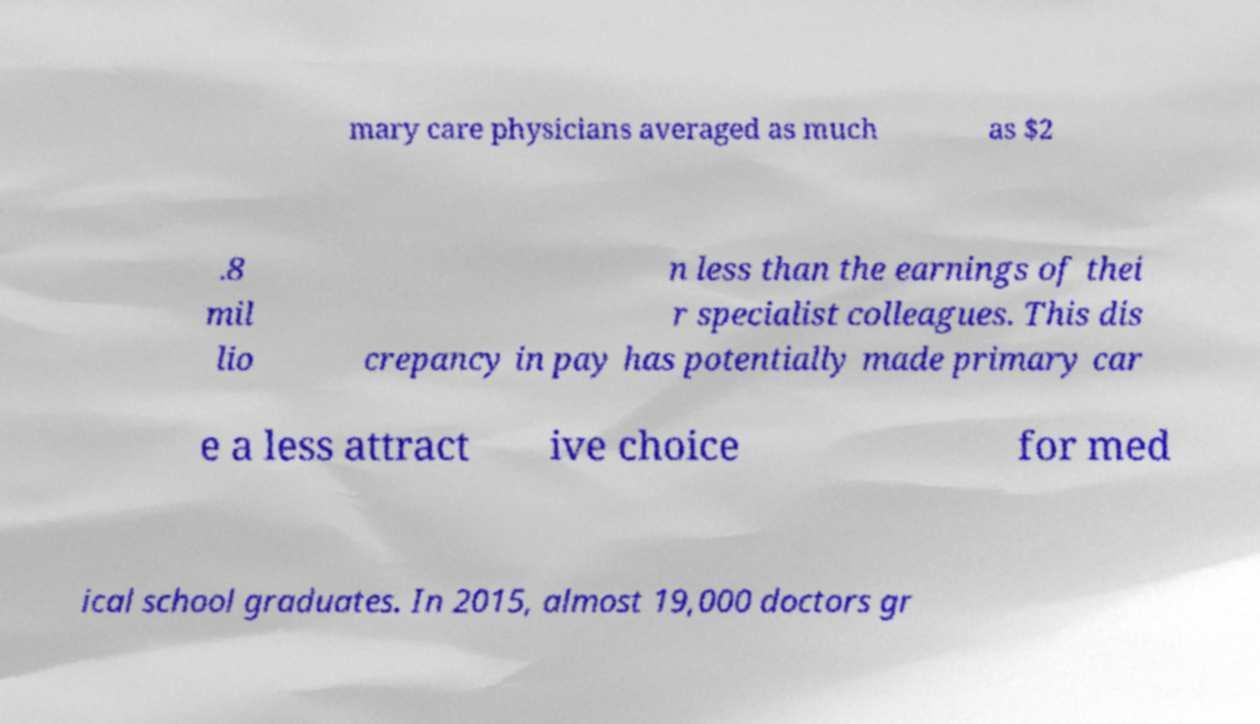Could you extract and type out the text from this image? mary care physicians averaged as much as $2 .8 mil lio n less than the earnings of thei r specialist colleagues. This dis crepancy in pay has potentially made primary car e a less attract ive choice for med ical school graduates. In 2015, almost 19,000 doctors gr 